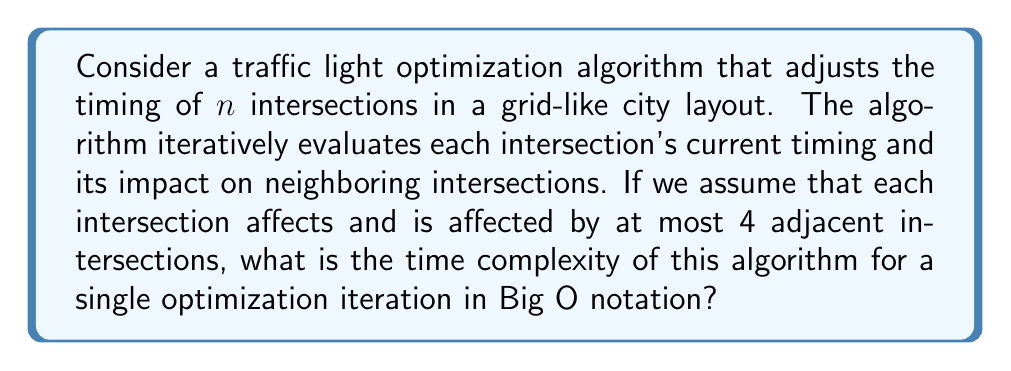Give your solution to this math problem. To analyze the time complexity of this algorithm, let's break it down step-by-step:

1. The algorithm needs to evaluate each of the $n$ intersections in the city.

2. For each intersection, it must consider:
   a) The current timing of the intersection itself
   b) The impact on and from up to 4 adjacent intersections

3. Let's assume that evaluating the timing of a single intersection and its impact takes constant time, $O(1)$.

4. For each intersection, the algorithm performs:
   - One evaluation for the intersection itself: $O(1)$
   - Up to 4 evaluations for adjacent intersections: $4 * O(1) = O(1)$

5. The total operations for a single intersection: $O(1) + O(1) = O(1)$

6. Since this process is repeated for all $n$ intersections, we multiply the complexity by $n$:

   $n * O(1) = O(n)$

Therefore, the time complexity for a single optimization iteration of this algorithm is $O(n)$, where $n$ is the number of intersections in the city.

This linear time complexity indicates that the algorithm's runtime grows proportionally with the number of intersections, which is relatively efficient for a city-wide optimization problem.
Answer: $O(n)$, where $n$ is the number of intersections in the city. 